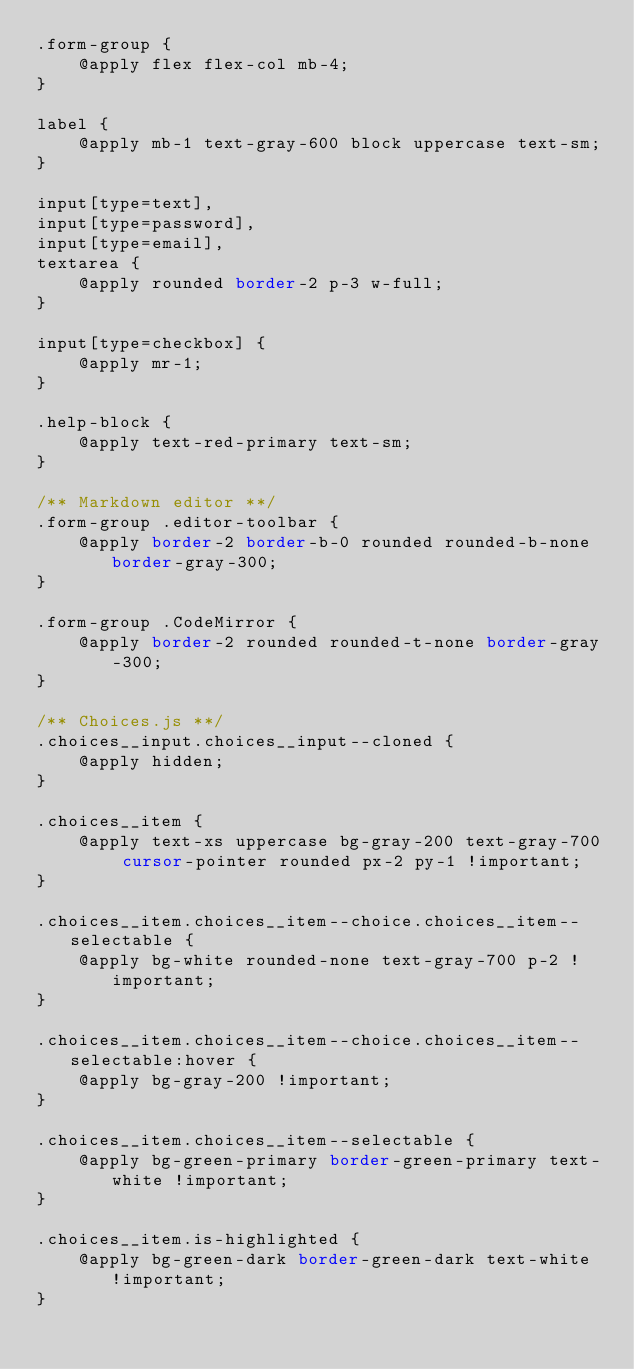Convert code to text. <code><loc_0><loc_0><loc_500><loc_500><_CSS_>.form-group {
    @apply flex flex-col mb-4;
}

label {
    @apply mb-1 text-gray-600 block uppercase text-sm;
}

input[type=text],
input[type=password],
input[type=email],
textarea {
    @apply rounded border-2 p-3 w-full;
}

input[type=checkbox] {
    @apply mr-1;
}

.help-block {
    @apply text-red-primary text-sm;
}

/** Markdown editor **/
.form-group .editor-toolbar {
    @apply border-2 border-b-0 rounded rounded-b-none border-gray-300;
}

.form-group .CodeMirror {
    @apply border-2 rounded rounded-t-none border-gray-300;
}

/** Choices.js **/
.choices__input.choices__input--cloned {
    @apply hidden;
}

.choices__item {
    @apply text-xs uppercase bg-gray-200 text-gray-700 cursor-pointer rounded px-2 py-1 !important;
}

.choices__item.choices__item--choice.choices__item--selectable {
    @apply bg-white rounded-none text-gray-700 p-2 !important;
}

.choices__item.choices__item--choice.choices__item--selectable:hover {
    @apply bg-gray-200 !important;
}

.choices__item.choices__item--selectable {
    @apply bg-green-primary border-green-primary text-white !important;
}

.choices__item.is-highlighted {
    @apply bg-green-dark border-green-dark text-white !important;
}</code> 